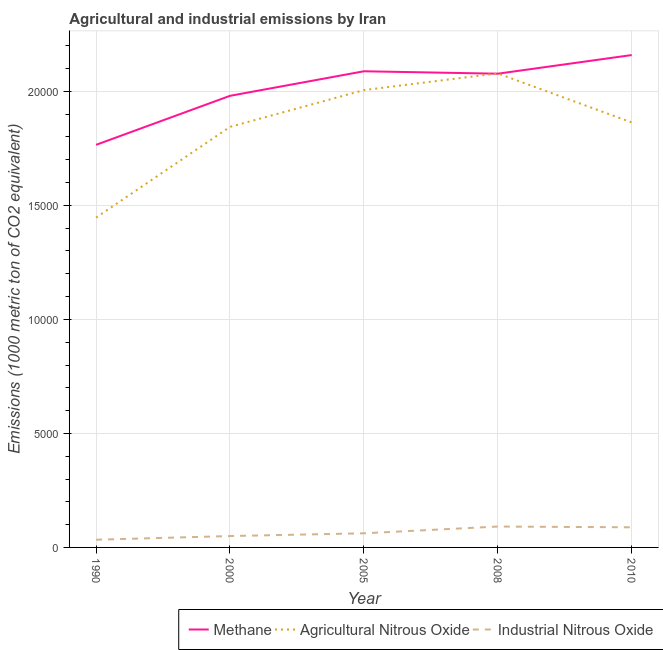Does the line corresponding to amount of industrial nitrous oxide emissions intersect with the line corresponding to amount of methane emissions?
Ensure brevity in your answer.  No. What is the amount of industrial nitrous oxide emissions in 2005?
Keep it short and to the point. 619.4. Across all years, what is the maximum amount of agricultural nitrous oxide emissions?
Offer a very short reply. 2.08e+04. Across all years, what is the minimum amount of methane emissions?
Keep it short and to the point. 1.77e+04. In which year was the amount of industrial nitrous oxide emissions maximum?
Provide a short and direct response. 2008. What is the total amount of agricultural nitrous oxide emissions in the graph?
Offer a terse response. 9.24e+04. What is the difference between the amount of industrial nitrous oxide emissions in 2000 and that in 2010?
Provide a succinct answer. -383.1. What is the difference between the amount of methane emissions in 2010 and the amount of industrial nitrous oxide emissions in 2005?
Offer a very short reply. 2.10e+04. What is the average amount of industrial nitrous oxide emissions per year?
Keep it short and to the point. 651.02. In the year 2008, what is the difference between the amount of methane emissions and amount of industrial nitrous oxide emissions?
Your answer should be compact. 1.99e+04. What is the ratio of the amount of methane emissions in 2000 to that in 2010?
Your answer should be very brief. 0.92. Is the amount of industrial nitrous oxide emissions in 1990 less than that in 2010?
Offer a very short reply. Yes. Is the difference between the amount of industrial nitrous oxide emissions in 1990 and 2010 greater than the difference between the amount of methane emissions in 1990 and 2010?
Make the answer very short. Yes. What is the difference between the highest and the second highest amount of methane emissions?
Your answer should be very brief. 710.8. What is the difference between the highest and the lowest amount of industrial nitrous oxide emissions?
Provide a short and direct response. 578.6. Does the amount of agricultural nitrous oxide emissions monotonically increase over the years?
Ensure brevity in your answer.  No. Is the amount of methane emissions strictly greater than the amount of agricultural nitrous oxide emissions over the years?
Your answer should be compact. No. Is the amount of methane emissions strictly less than the amount of industrial nitrous oxide emissions over the years?
Provide a short and direct response. No. How many years are there in the graph?
Make the answer very short. 5. What is the difference between two consecutive major ticks on the Y-axis?
Ensure brevity in your answer.  5000. Where does the legend appear in the graph?
Make the answer very short. Bottom right. How are the legend labels stacked?
Provide a succinct answer. Horizontal. What is the title of the graph?
Ensure brevity in your answer.  Agricultural and industrial emissions by Iran. Does "Gaseous fuel" appear as one of the legend labels in the graph?
Keep it short and to the point. No. What is the label or title of the X-axis?
Provide a succinct answer. Year. What is the label or title of the Y-axis?
Ensure brevity in your answer.  Emissions (1000 metric ton of CO2 equivalent). What is the Emissions (1000 metric ton of CO2 equivalent) of Methane in 1990?
Your answer should be very brief. 1.77e+04. What is the Emissions (1000 metric ton of CO2 equivalent) of Agricultural Nitrous Oxide in 1990?
Your response must be concise. 1.45e+04. What is the Emissions (1000 metric ton of CO2 equivalent) of Industrial Nitrous Oxide in 1990?
Offer a very short reply. 337.6. What is the Emissions (1000 metric ton of CO2 equivalent) in Methane in 2000?
Make the answer very short. 1.98e+04. What is the Emissions (1000 metric ton of CO2 equivalent) of Agricultural Nitrous Oxide in 2000?
Your answer should be compact. 1.84e+04. What is the Emissions (1000 metric ton of CO2 equivalent) of Industrial Nitrous Oxide in 2000?
Offer a terse response. 499.4. What is the Emissions (1000 metric ton of CO2 equivalent) of Methane in 2005?
Make the answer very short. 2.09e+04. What is the Emissions (1000 metric ton of CO2 equivalent) in Agricultural Nitrous Oxide in 2005?
Provide a succinct answer. 2.01e+04. What is the Emissions (1000 metric ton of CO2 equivalent) in Industrial Nitrous Oxide in 2005?
Your answer should be very brief. 619.4. What is the Emissions (1000 metric ton of CO2 equivalent) in Methane in 2008?
Your answer should be compact. 2.08e+04. What is the Emissions (1000 metric ton of CO2 equivalent) of Agricultural Nitrous Oxide in 2008?
Keep it short and to the point. 2.08e+04. What is the Emissions (1000 metric ton of CO2 equivalent) in Industrial Nitrous Oxide in 2008?
Provide a short and direct response. 916.2. What is the Emissions (1000 metric ton of CO2 equivalent) in Methane in 2010?
Your answer should be very brief. 2.16e+04. What is the Emissions (1000 metric ton of CO2 equivalent) of Agricultural Nitrous Oxide in 2010?
Keep it short and to the point. 1.86e+04. What is the Emissions (1000 metric ton of CO2 equivalent) in Industrial Nitrous Oxide in 2010?
Provide a short and direct response. 882.5. Across all years, what is the maximum Emissions (1000 metric ton of CO2 equivalent) of Methane?
Offer a terse response. 2.16e+04. Across all years, what is the maximum Emissions (1000 metric ton of CO2 equivalent) of Agricultural Nitrous Oxide?
Ensure brevity in your answer.  2.08e+04. Across all years, what is the maximum Emissions (1000 metric ton of CO2 equivalent) of Industrial Nitrous Oxide?
Keep it short and to the point. 916.2. Across all years, what is the minimum Emissions (1000 metric ton of CO2 equivalent) in Methane?
Give a very brief answer. 1.77e+04. Across all years, what is the minimum Emissions (1000 metric ton of CO2 equivalent) of Agricultural Nitrous Oxide?
Give a very brief answer. 1.45e+04. Across all years, what is the minimum Emissions (1000 metric ton of CO2 equivalent) of Industrial Nitrous Oxide?
Your answer should be compact. 337.6. What is the total Emissions (1000 metric ton of CO2 equivalent) of Methane in the graph?
Your answer should be compact. 1.01e+05. What is the total Emissions (1000 metric ton of CO2 equivalent) of Agricultural Nitrous Oxide in the graph?
Your response must be concise. 9.24e+04. What is the total Emissions (1000 metric ton of CO2 equivalent) in Industrial Nitrous Oxide in the graph?
Offer a terse response. 3255.1. What is the difference between the Emissions (1000 metric ton of CO2 equivalent) of Methane in 1990 and that in 2000?
Provide a short and direct response. -2149.4. What is the difference between the Emissions (1000 metric ton of CO2 equivalent) in Agricultural Nitrous Oxide in 1990 and that in 2000?
Your answer should be very brief. -3977.6. What is the difference between the Emissions (1000 metric ton of CO2 equivalent) in Industrial Nitrous Oxide in 1990 and that in 2000?
Provide a succinct answer. -161.8. What is the difference between the Emissions (1000 metric ton of CO2 equivalent) in Methane in 1990 and that in 2005?
Your answer should be very brief. -3226.3. What is the difference between the Emissions (1000 metric ton of CO2 equivalent) of Agricultural Nitrous Oxide in 1990 and that in 2005?
Your answer should be compact. -5590.3. What is the difference between the Emissions (1000 metric ton of CO2 equivalent) of Industrial Nitrous Oxide in 1990 and that in 2005?
Provide a succinct answer. -281.8. What is the difference between the Emissions (1000 metric ton of CO2 equivalent) of Methane in 1990 and that in 2008?
Your answer should be very brief. -3119.6. What is the difference between the Emissions (1000 metric ton of CO2 equivalent) of Agricultural Nitrous Oxide in 1990 and that in 2008?
Provide a short and direct response. -6323.6. What is the difference between the Emissions (1000 metric ton of CO2 equivalent) of Industrial Nitrous Oxide in 1990 and that in 2008?
Provide a short and direct response. -578.6. What is the difference between the Emissions (1000 metric ton of CO2 equivalent) of Methane in 1990 and that in 2010?
Your answer should be compact. -3937.1. What is the difference between the Emissions (1000 metric ton of CO2 equivalent) of Agricultural Nitrous Oxide in 1990 and that in 2010?
Give a very brief answer. -4171.6. What is the difference between the Emissions (1000 metric ton of CO2 equivalent) of Industrial Nitrous Oxide in 1990 and that in 2010?
Give a very brief answer. -544.9. What is the difference between the Emissions (1000 metric ton of CO2 equivalent) in Methane in 2000 and that in 2005?
Provide a succinct answer. -1076.9. What is the difference between the Emissions (1000 metric ton of CO2 equivalent) of Agricultural Nitrous Oxide in 2000 and that in 2005?
Offer a terse response. -1612.7. What is the difference between the Emissions (1000 metric ton of CO2 equivalent) of Industrial Nitrous Oxide in 2000 and that in 2005?
Your answer should be compact. -120. What is the difference between the Emissions (1000 metric ton of CO2 equivalent) of Methane in 2000 and that in 2008?
Make the answer very short. -970.2. What is the difference between the Emissions (1000 metric ton of CO2 equivalent) in Agricultural Nitrous Oxide in 2000 and that in 2008?
Provide a succinct answer. -2346. What is the difference between the Emissions (1000 metric ton of CO2 equivalent) of Industrial Nitrous Oxide in 2000 and that in 2008?
Make the answer very short. -416.8. What is the difference between the Emissions (1000 metric ton of CO2 equivalent) in Methane in 2000 and that in 2010?
Offer a terse response. -1787.7. What is the difference between the Emissions (1000 metric ton of CO2 equivalent) of Agricultural Nitrous Oxide in 2000 and that in 2010?
Your answer should be very brief. -194. What is the difference between the Emissions (1000 metric ton of CO2 equivalent) in Industrial Nitrous Oxide in 2000 and that in 2010?
Offer a very short reply. -383.1. What is the difference between the Emissions (1000 metric ton of CO2 equivalent) in Methane in 2005 and that in 2008?
Give a very brief answer. 106.7. What is the difference between the Emissions (1000 metric ton of CO2 equivalent) of Agricultural Nitrous Oxide in 2005 and that in 2008?
Give a very brief answer. -733.3. What is the difference between the Emissions (1000 metric ton of CO2 equivalent) of Industrial Nitrous Oxide in 2005 and that in 2008?
Offer a very short reply. -296.8. What is the difference between the Emissions (1000 metric ton of CO2 equivalent) of Methane in 2005 and that in 2010?
Keep it short and to the point. -710.8. What is the difference between the Emissions (1000 metric ton of CO2 equivalent) in Agricultural Nitrous Oxide in 2005 and that in 2010?
Provide a succinct answer. 1418.7. What is the difference between the Emissions (1000 metric ton of CO2 equivalent) of Industrial Nitrous Oxide in 2005 and that in 2010?
Your answer should be very brief. -263.1. What is the difference between the Emissions (1000 metric ton of CO2 equivalent) in Methane in 2008 and that in 2010?
Offer a very short reply. -817.5. What is the difference between the Emissions (1000 metric ton of CO2 equivalent) of Agricultural Nitrous Oxide in 2008 and that in 2010?
Your answer should be very brief. 2152. What is the difference between the Emissions (1000 metric ton of CO2 equivalent) in Industrial Nitrous Oxide in 2008 and that in 2010?
Provide a succinct answer. 33.7. What is the difference between the Emissions (1000 metric ton of CO2 equivalent) of Methane in 1990 and the Emissions (1000 metric ton of CO2 equivalent) of Agricultural Nitrous Oxide in 2000?
Make the answer very short. -787.4. What is the difference between the Emissions (1000 metric ton of CO2 equivalent) in Methane in 1990 and the Emissions (1000 metric ton of CO2 equivalent) in Industrial Nitrous Oxide in 2000?
Give a very brief answer. 1.72e+04. What is the difference between the Emissions (1000 metric ton of CO2 equivalent) of Agricultural Nitrous Oxide in 1990 and the Emissions (1000 metric ton of CO2 equivalent) of Industrial Nitrous Oxide in 2000?
Ensure brevity in your answer.  1.40e+04. What is the difference between the Emissions (1000 metric ton of CO2 equivalent) of Methane in 1990 and the Emissions (1000 metric ton of CO2 equivalent) of Agricultural Nitrous Oxide in 2005?
Ensure brevity in your answer.  -2400.1. What is the difference between the Emissions (1000 metric ton of CO2 equivalent) in Methane in 1990 and the Emissions (1000 metric ton of CO2 equivalent) in Industrial Nitrous Oxide in 2005?
Keep it short and to the point. 1.70e+04. What is the difference between the Emissions (1000 metric ton of CO2 equivalent) of Agricultural Nitrous Oxide in 1990 and the Emissions (1000 metric ton of CO2 equivalent) of Industrial Nitrous Oxide in 2005?
Provide a succinct answer. 1.38e+04. What is the difference between the Emissions (1000 metric ton of CO2 equivalent) in Methane in 1990 and the Emissions (1000 metric ton of CO2 equivalent) in Agricultural Nitrous Oxide in 2008?
Ensure brevity in your answer.  -3133.4. What is the difference between the Emissions (1000 metric ton of CO2 equivalent) of Methane in 1990 and the Emissions (1000 metric ton of CO2 equivalent) of Industrial Nitrous Oxide in 2008?
Ensure brevity in your answer.  1.67e+04. What is the difference between the Emissions (1000 metric ton of CO2 equivalent) in Agricultural Nitrous Oxide in 1990 and the Emissions (1000 metric ton of CO2 equivalent) in Industrial Nitrous Oxide in 2008?
Make the answer very short. 1.35e+04. What is the difference between the Emissions (1000 metric ton of CO2 equivalent) in Methane in 1990 and the Emissions (1000 metric ton of CO2 equivalent) in Agricultural Nitrous Oxide in 2010?
Ensure brevity in your answer.  -981.4. What is the difference between the Emissions (1000 metric ton of CO2 equivalent) in Methane in 1990 and the Emissions (1000 metric ton of CO2 equivalent) in Industrial Nitrous Oxide in 2010?
Offer a very short reply. 1.68e+04. What is the difference between the Emissions (1000 metric ton of CO2 equivalent) of Agricultural Nitrous Oxide in 1990 and the Emissions (1000 metric ton of CO2 equivalent) of Industrial Nitrous Oxide in 2010?
Your answer should be compact. 1.36e+04. What is the difference between the Emissions (1000 metric ton of CO2 equivalent) in Methane in 2000 and the Emissions (1000 metric ton of CO2 equivalent) in Agricultural Nitrous Oxide in 2005?
Keep it short and to the point. -250.7. What is the difference between the Emissions (1000 metric ton of CO2 equivalent) in Methane in 2000 and the Emissions (1000 metric ton of CO2 equivalent) in Industrial Nitrous Oxide in 2005?
Provide a short and direct response. 1.92e+04. What is the difference between the Emissions (1000 metric ton of CO2 equivalent) of Agricultural Nitrous Oxide in 2000 and the Emissions (1000 metric ton of CO2 equivalent) of Industrial Nitrous Oxide in 2005?
Give a very brief answer. 1.78e+04. What is the difference between the Emissions (1000 metric ton of CO2 equivalent) in Methane in 2000 and the Emissions (1000 metric ton of CO2 equivalent) in Agricultural Nitrous Oxide in 2008?
Offer a very short reply. -984. What is the difference between the Emissions (1000 metric ton of CO2 equivalent) of Methane in 2000 and the Emissions (1000 metric ton of CO2 equivalent) of Industrial Nitrous Oxide in 2008?
Give a very brief answer. 1.89e+04. What is the difference between the Emissions (1000 metric ton of CO2 equivalent) in Agricultural Nitrous Oxide in 2000 and the Emissions (1000 metric ton of CO2 equivalent) in Industrial Nitrous Oxide in 2008?
Your response must be concise. 1.75e+04. What is the difference between the Emissions (1000 metric ton of CO2 equivalent) of Methane in 2000 and the Emissions (1000 metric ton of CO2 equivalent) of Agricultural Nitrous Oxide in 2010?
Make the answer very short. 1168. What is the difference between the Emissions (1000 metric ton of CO2 equivalent) of Methane in 2000 and the Emissions (1000 metric ton of CO2 equivalent) of Industrial Nitrous Oxide in 2010?
Keep it short and to the point. 1.89e+04. What is the difference between the Emissions (1000 metric ton of CO2 equivalent) of Agricultural Nitrous Oxide in 2000 and the Emissions (1000 metric ton of CO2 equivalent) of Industrial Nitrous Oxide in 2010?
Provide a short and direct response. 1.76e+04. What is the difference between the Emissions (1000 metric ton of CO2 equivalent) in Methane in 2005 and the Emissions (1000 metric ton of CO2 equivalent) in Agricultural Nitrous Oxide in 2008?
Give a very brief answer. 92.9. What is the difference between the Emissions (1000 metric ton of CO2 equivalent) of Methane in 2005 and the Emissions (1000 metric ton of CO2 equivalent) of Industrial Nitrous Oxide in 2008?
Offer a very short reply. 2.00e+04. What is the difference between the Emissions (1000 metric ton of CO2 equivalent) of Agricultural Nitrous Oxide in 2005 and the Emissions (1000 metric ton of CO2 equivalent) of Industrial Nitrous Oxide in 2008?
Offer a very short reply. 1.91e+04. What is the difference between the Emissions (1000 metric ton of CO2 equivalent) of Methane in 2005 and the Emissions (1000 metric ton of CO2 equivalent) of Agricultural Nitrous Oxide in 2010?
Keep it short and to the point. 2244.9. What is the difference between the Emissions (1000 metric ton of CO2 equivalent) in Methane in 2005 and the Emissions (1000 metric ton of CO2 equivalent) in Industrial Nitrous Oxide in 2010?
Ensure brevity in your answer.  2.00e+04. What is the difference between the Emissions (1000 metric ton of CO2 equivalent) of Agricultural Nitrous Oxide in 2005 and the Emissions (1000 metric ton of CO2 equivalent) of Industrial Nitrous Oxide in 2010?
Offer a very short reply. 1.92e+04. What is the difference between the Emissions (1000 metric ton of CO2 equivalent) in Methane in 2008 and the Emissions (1000 metric ton of CO2 equivalent) in Agricultural Nitrous Oxide in 2010?
Your answer should be very brief. 2138.2. What is the difference between the Emissions (1000 metric ton of CO2 equivalent) in Methane in 2008 and the Emissions (1000 metric ton of CO2 equivalent) in Industrial Nitrous Oxide in 2010?
Provide a short and direct response. 1.99e+04. What is the difference between the Emissions (1000 metric ton of CO2 equivalent) of Agricultural Nitrous Oxide in 2008 and the Emissions (1000 metric ton of CO2 equivalent) of Industrial Nitrous Oxide in 2010?
Offer a terse response. 1.99e+04. What is the average Emissions (1000 metric ton of CO2 equivalent) in Methane per year?
Make the answer very short. 2.01e+04. What is the average Emissions (1000 metric ton of CO2 equivalent) in Agricultural Nitrous Oxide per year?
Your answer should be very brief. 1.85e+04. What is the average Emissions (1000 metric ton of CO2 equivalent) of Industrial Nitrous Oxide per year?
Offer a very short reply. 651.02. In the year 1990, what is the difference between the Emissions (1000 metric ton of CO2 equivalent) in Methane and Emissions (1000 metric ton of CO2 equivalent) in Agricultural Nitrous Oxide?
Make the answer very short. 3190.2. In the year 1990, what is the difference between the Emissions (1000 metric ton of CO2 equivalent) in Methane and Emissions (1000 metric ton of CO2 equivalent) in Industrial Nitrous Oxide?
Make the answer very short. 1.73e+04. In the year 1990, what is the difference between the Emissions (1000 metric ton of CO2 equivalent) of Agricultural Nitrous Oxide and Emissions (1000 metric ton of CO2 equivalent) of Industrial Nitrous Oxide?
Offer a very short reply. 1.41e+04. In the year 2000, what is the difference between the Emissions (1000 metric ton of CO2 equivalent) in Methane and Emissions (1000 metric ton of CO2 equivalent) in Agricultural Nitrous Oxide?
Provide a short and direct response. 1362. In the year 2000, what is the difference between the Emissions (1000 metric ton of CO2 equivalent) in Methane and Emissions (1000 metric ton of CO2 equivalent) in Industrial Nitrous Oxide?
Provide a succinct answer. 1.93e+04. In the year 2000, what is the difference between the Emissions (1000 metric ton of CO2 equivalent) in Agricultural Nitrous Oxide and Emissions (1000 metric ton of CO2 equivalent) in Industrial Nitrous Oxide?
Offer a terse response. 1.79e+04. In the year 2005, what is the difference between the Emissions (1000 metric ton of CO2 equivalent) in Methane and Emissions (1000 metric ton of CO2 equivalent) in Agricultural Nitrous Oxide?
Give a very brief answer. 826.2. In the year 2005, what is the difference between the Emissions (1000 metric ton of CO2 equivalent) of Methane and Emissions (1000 metric ton of CO2 equivalent) of Industrial Nitrous Oxide?
Give a very brief answer. 2.03e+04. In the year 2005, what is the difference between the Emissions (1000 metric ton of CO2 equivalent) of Agricultural Nitrous Oxide and Emissions (1000 metric ton of CO2 equivalent) of Industrial Nitrous Oxide?
Provide a short and direct response. 1.94e+04. In the year 2008, what is the difference between the Emissions (1000 metric ton of CO2 equivalent) of Methane and Emissions (1000 metric ton of CO2 equivalent) of Agricultural Nitrous Oxide?
Provide a succinct answer. -13.8. In the year 2008, what is the difference between the Emissions (1000 metric ton of CO2 equivalent) of Methane and Emissions (1000 metric ton of CO2 equivalent) of Industrial Nitrous Oxide?
Make the answer very short. 1.99e+04. In the year 2008, what is the difference between the Emissions (1000 metric ton of CO2 equivalent) of Agricultural Nitrous Oxide and Emissions (1000 metric ton of CO2 equivalent) of Industrial Nitrous Oxide?
Make the answer very short. 1.99e+04. In the year 2010, what is the difference between the Emissions (1000 metric ton of CO2 equivalent) in Methane and Emissions (1000 metric ton of CO2 equivalent) in Agricultural Nitrous Oxide?
Give a very brief answer. 2955.7. In the year 2010, what is the difference between the Emissions (1000 metric ton of CO2 equivalent) in Methane and Emissions (1000 metric ton of CO2 equivalent) in Industrial Nitrous Oxide?
Your answer should be compact. 2.07e+04. In the year 2010, what is the difference between the Emissions (1000 metric ton of CO2 equivalent) in Agricultural Nitrous Oxide and Emissions (1000 metric ton of CO2 equivalent) in Industrial Nitrous Oxide?
Provide a succinct answer. 1.78e+04. What is the ratio of the Emissions (1000 metric ton of CO2 equivalent) of Methane in 1990 to that in 2000?
Your answer should be compact. 0.89. What is the ratio of the Emissions (1000 metric ton of CO2 equivalent) of Agricultural Nitrous Oxide in 1990 to that in 2000?
Make the answer very short. 0.78. What is the ratio of the Emissions (1000 metric ton of CO2 equivalent) in Industrial Nitrous Oxide in 1990 to that in 2000?
Offer a very short reply. 0.68. What is the ratio of the Emissions (1000 metric ton of CO2 equivalent) of Methane in 1990 to that in 2005?
Offer a terse response. 0.85. What is the ratio of the Emissions (1000 metric ton of CO2 equivalent) in Agricultural Nitrous Oxide in 1990 to that in 2005?
Give a very brief answer. 0.72. What is the ratio of the Emissions (1000 metric ton of CO2 equivalent) of Industrial Nitrous Oxide in 1990 to that in 2005?
Your answer should be very brief. 0.55. What is the ratio of the Emissions (1000 metric ton of CO2 equivalent) in Methane in 1990 to that in 2008?
Provide a succinct answer. 0.85. What is the ratio of the Emissions (1000 metric ton of CO2 equivalent) in Agricultural Nitrous Oxide in 1990 to that in 2008?
Ensure brevity in your answer.  0.7. What is the ratio of the Emissions (1000 metric ton of CO2 equivalent) of Industrial Nitrous Oxide in 1990 to that in 2008?
Ensure brevity in your answer.  0.37. What is the ratio of the Emissions (1000 metric ton of CO2 equivalent) in Methane in 1990 to that in 2010?
Ensure brevity in your answer.  0.82. What is the ratio of the Emissions (1000 metric ton of CO2 equivalent) of Agricultural Nitrous Oxide in 1990 to that in 2010?
Provide a succinct answer. 0.78. What is the ratio of the Emissions (1000 metric ton of CO2 equivalent) in Industrial Nitrous Oxide in 1990 to that in 2010?
Your answer should be very brief. 0.38. What is the ratio of the Emissions (1000 metric ton of CO2 equivalent) in Methane in 2000 to that in 2005?
Make the answer very short. 0.95. What is the ratio of the Emissions (1000 metric ton of CO2 equivalent) of Agricultural Nitrous Oxide in 2000 to that in 2005?
Your answer should be very brief. 0.92. What is the ratio of the Emissions (1000 metric ton of CO2 equivalent) in Industrial Nitrous Oxide in 2000 to that in 2005?
Your answer should be very brief. 0.81. What is the ratio of the Emissions (1000 metric ton of CO2 equivalent) in Methane in 2000 to that in 2008?
Make the answer very short. 0.95. What is the ratio of the Emissions (1000 metric ton of CO2 equivalent) in Agricultural Nitrous Oxide in 2000 to that in 2008?
Provide a succinct answer. 0.89. What is the ratio of the Emissions (1000 metric ton of CO2 equivalent) in Industrial Nitrous Oxide in 2000 to that in 2008?
Ensure brevity in your answer.  0.55. What is the ratio of the Emissions (1000 metric ton of CO2 equivalent) in Methane in 2000 to that in 2010?
Your answer should be compact. 0.92. What is the ratio of the Emissions (1000 metric ton of CO2 equivalent) in Industrial Nitrous Oxide in 2000 to that in 2010?
Your answer should be compact. 0.57. What is the ratio of the Emissions (1000 metric ton of CO2 equivalent) of Methane in 2005 to that in 2008?
Give a very brief answer. 1.01. What is the ratio of the Emissions (1000 metric ton of CO2 equivalent) of Agricultural Nitrous Oxide in 2005 to that in 2008?
Give a very brief answer. 0.96. What is the ratio of the Emissions (1000 metric ton of CO2 equivalent) in Industrial Nitrous Oxide in 2005 to that in 2008?
Provide a short and direct response. 0.68. What is the ratio of the Emissions (1000 metric ton of CO2 equivalent) of Methane in 2005 to that in 2010?
Provide a short and direct response. 0.97. What is the ratio of the Emissions (1000 metric ton of CO2 equivalent) in Agricultural Nitrous Oxide in 2005 to that in 2010?
Offer a terse response. 1.08. What is the ratio of the Emissions (1000 metric ton of CO2 equivalent) of Industrial Nitrous Oxide in 2005 to that in 2010?
Ensure brevity in your answer.  0.7. What is the ratio of the Emissions (1000 metric ton of CO2 equivalent) in Methane in 2008 to that in 2010?
Your answer should be very brief. 0.96. What is the ratio of the Emissions (1000 metric ton of CO2 equivalent) in Agricultural Nitrous Oxide in 2008 to that in 2010?
Give a very brief answer. 1.12. What is the ratio of the Emissions (1000 metric ton of CO2 equivalent) of Industrial Nitrous Oxide in 2008 to that in 2010?
Your answer should be very brief. 1.04. What is the difference between the highest and the second highest Emissions (1000 metric ton of CO2 equivalent) of Methane?
Keep it short and to the point. 710.8. What is the difference between the highest and the second highest Emissions (1000 metric ton of CO2 equivalent) in Agricultural Nitrous Oxide?
Give a very brief answer. 733.3. What is the difference between the highest and the second highest Emissions (1000 metric ton of CO2 equivalent) of Industrial Nitrous Oxide?
Your answer should be very brief. 33.7. What is the difference between the highest and the lowest Emissions (1000 metric ton of CO2 equivalent) of Methane?
Offer a very short reply. 3937.1. What is the difference between the highest and the lowest Emissions (1000 metric ton of CO2 equivalent) of Agricultural Nitrous Oxide?
Offer a terse response. 6323.6. What is the difference between the highest and the lowest Emissions (1000 metric ton of CO2 equivalent) in Industrial Nitrous Oxide?
Ensure brevity in your answer.  578.6. 